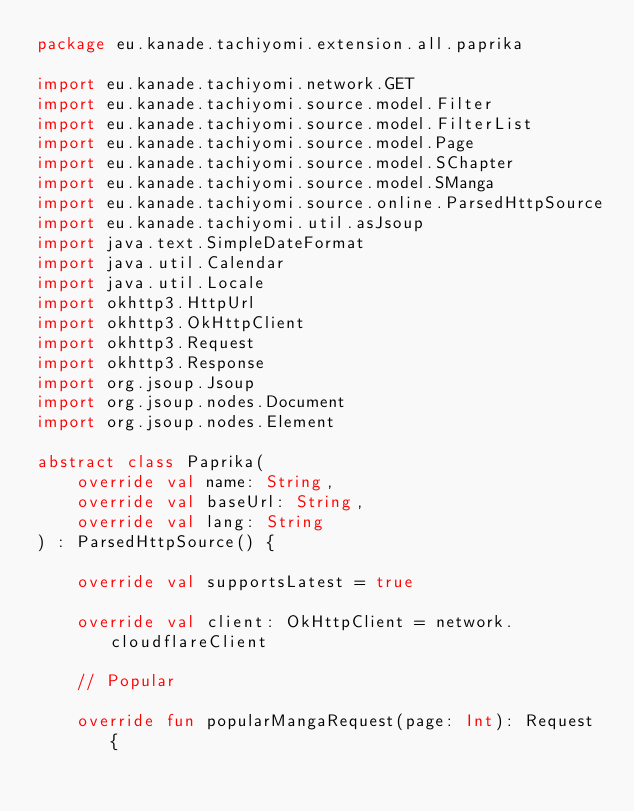Convert code to text. <code><loc_0><loc_0><loc_500><loc_500><_Kotlin_>package eu.kanade.tachiyomi.extension.all.paprika

import eu.kanade.tachiyomi.network.GET
import eu.kanade.tachiyomi.source.model.Filter
import eu.kanade.tachiyomi.source.model.FilterList
import eu.kanade.tachiyomi.source.model.Page
import eu.kanade.tachiyomi.source.model.SChapter
import eu.kanade.tachiyomi.source.model.SManga
import eu.kanade.tachiyomi.source.online.ParsedHttpSource
import eu.kanade.tachiyomi.util.asJsoup
import java.text.SimpleDateFormat
import java.util.Calendar
import java.util.Locale
import okhttp3.HttpUrl
import okhttp3.OkHttpClient
import okhttp3.Request
import okhttp3.Response
import org.jsoup.Jsoup
import org.jsoup.nodes.Document
import org.jsoup.nodes.Element

abstract class Paprika(
    override val name: String,
    override val baseUrl: String,
    override val lang: String
) : ParsedHttpSource() {

    override val supportsLatest = true

    override val client: OkHttpClient = network.cloudflareClient

    // Popular

    override fun popularMangaRequest(page: Int): Request {</code> 